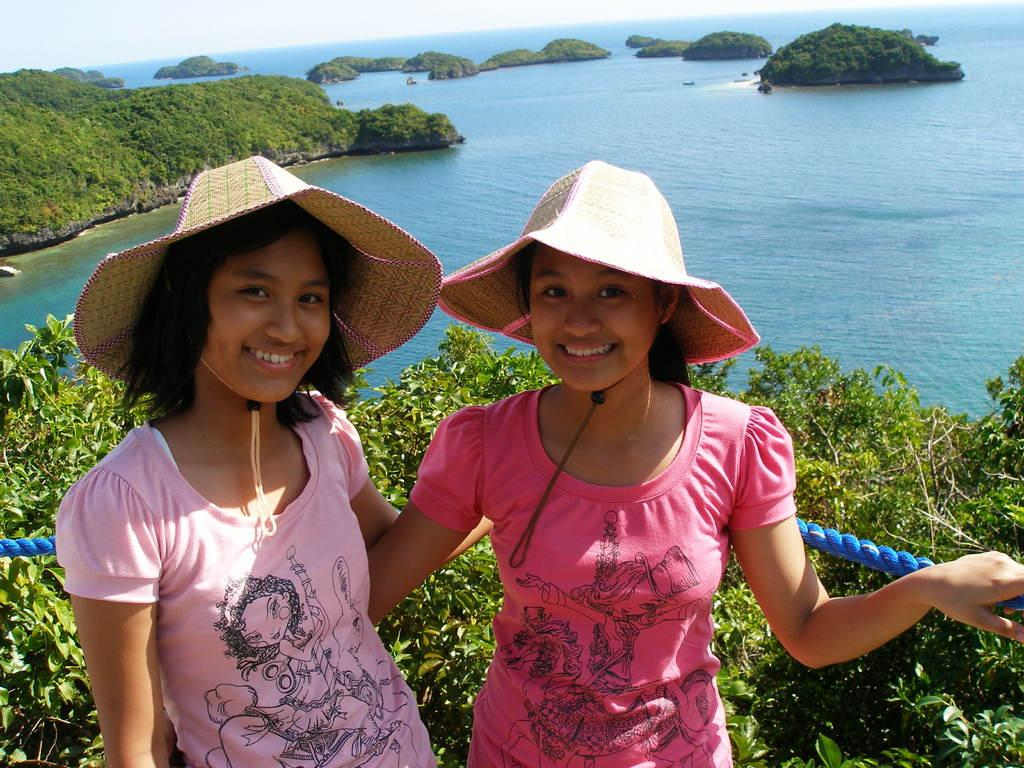How many girls are in the image? There are two girls in the image. What are the girls doing in the image? The girls are watching and smiling in the image. What are the girls wearing on their heads? The girls are wearing hats in the image. What color is the rope visible in the image? The rope in the image is blue. What type of natural environment can be seen in the image? The background of the image includes trees, hills, plants, and water. What type of game are the girls playing in the image? There is no game visible in the image; the girls are simply watching and smiling. How many cars can be seen in the image? There are no cars present in the image. 